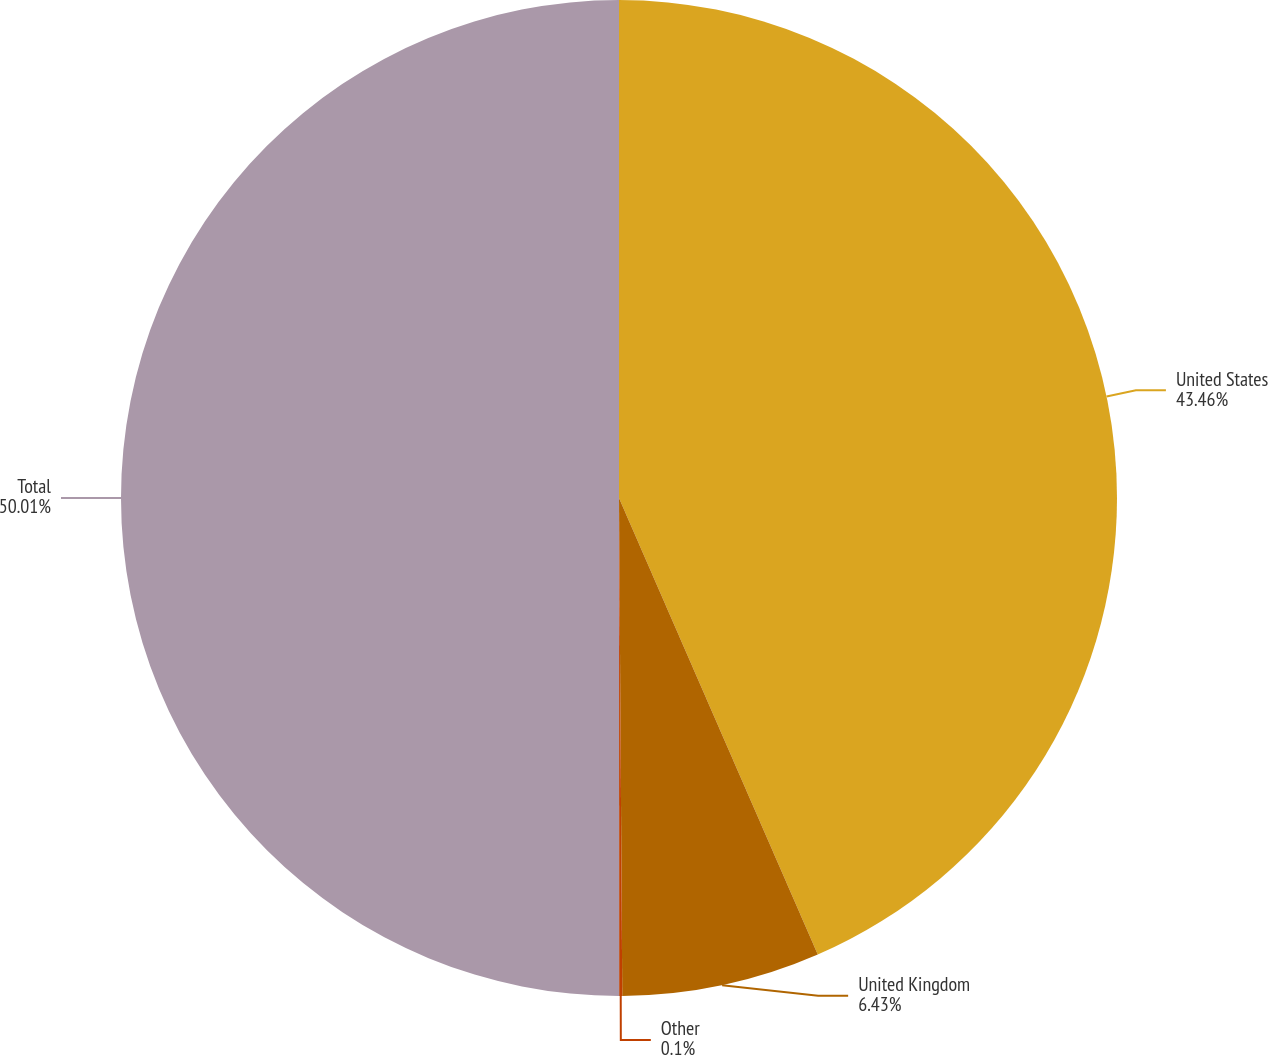Convert chart to OTSL. <chart><loc_0><loc_0><loc_500><loc_500><pie_chart><fcel>United States<fcel>United Kingdom<fcel>Other<fcel>Total<nl><fcel>43.46%<fcel>6.43%<fcel>0.1%<fcel>50.0%<nl></chart> 